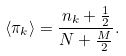<formula> <loc_0><loc_0><loc_500><loc_500>\langle \pi _ { k } \rangle = \frac { n _ { k } + \frac { 1 } { 2 } } { N + \frac { M } { 2 } } .</formula> 